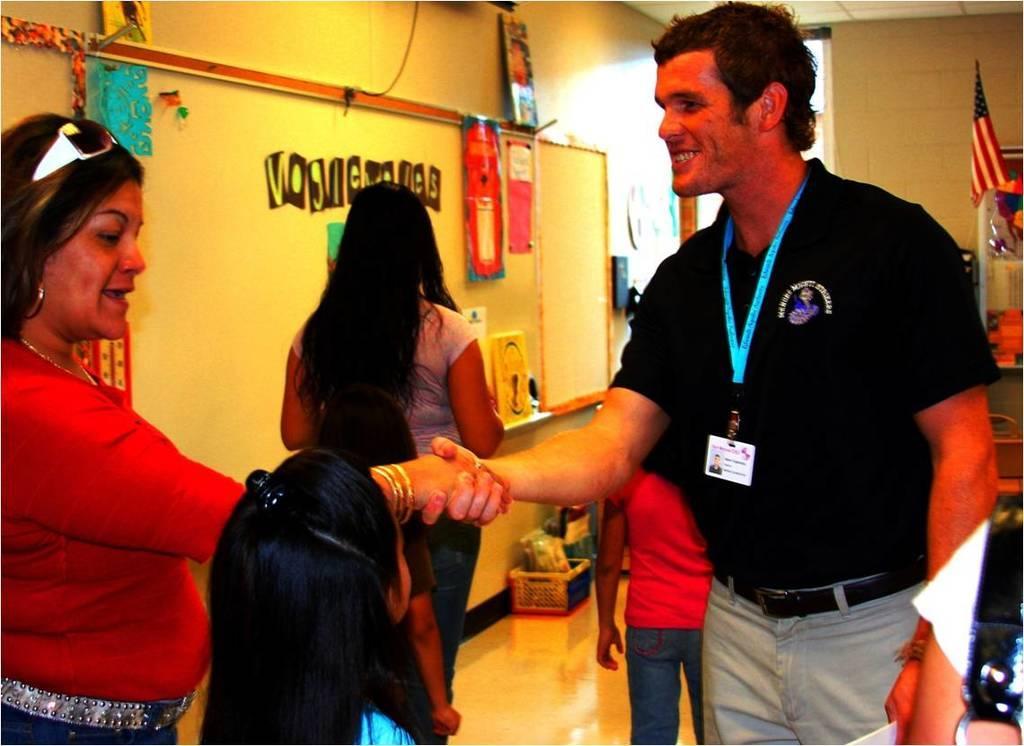Describe this image in one or two sentences. In this image in the foreground there are two persons standing and smiling, and they are shaking hands with each other. And there is one girl standing and in the background there are two persons walking, on the left side there is a wall and on the wall there are some posters and photo frames. On the right side there is a flag, wall and some other objects. At the bottom there is a floor, on the floor there is a basket and bags and in the background there are some objects. 